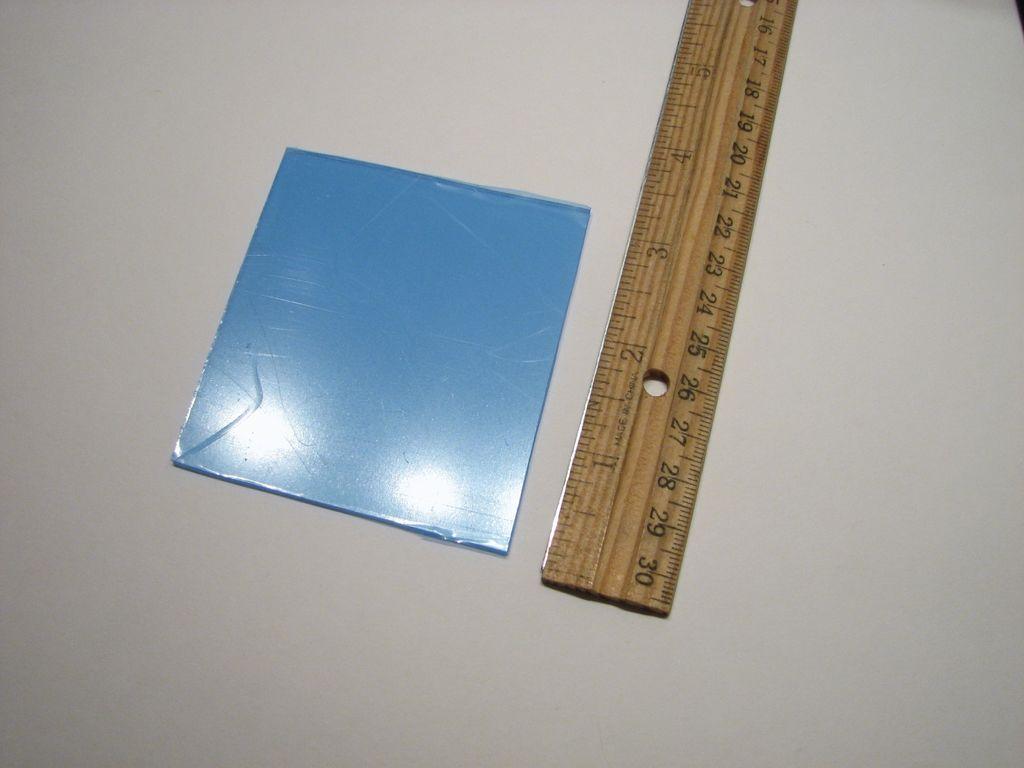What is the length of the blue object?
Ensure brevity in your answer.  3 inches. What is the largest number on the ruler?
Make the answer very short. 30. 